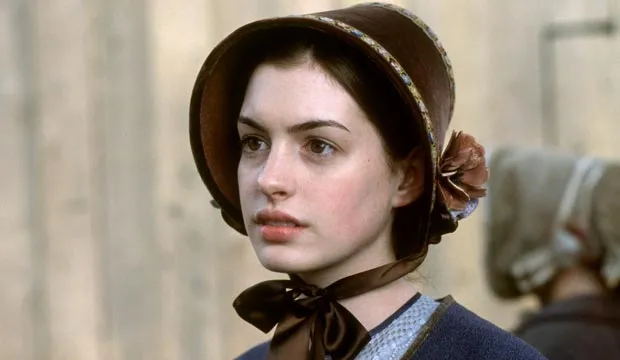Can you describe the overall mood or atmosphere this image evokes? The image evokes a somber and reflective mood. The woman's serious expression, coupled with the muted colors of her clothing and the historic setting, suggest a narrative filled with emotional depth. The background adds a layer of activity that contrasts with her introspective demeanor, creating a dynamic yet contemplative atmosphere. 